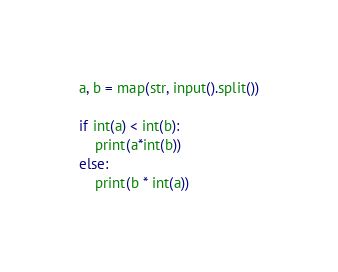Convert code to text. <code><loc_0><loc_0><loc_500><loc_500><_Python_>a, b = map(str, input().split())

if int(a) < int(b):
    print(a*int(b))
else:
    print(b * int(a))</code> 